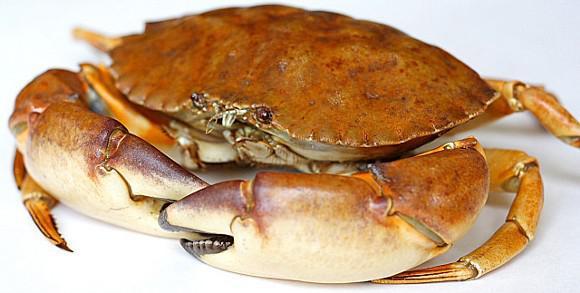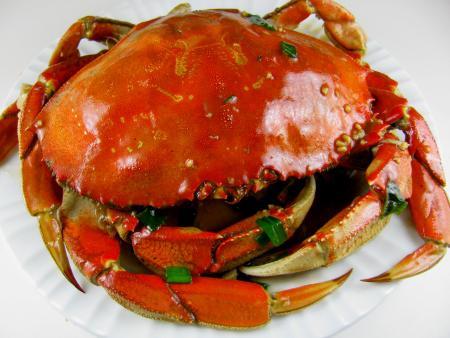The first image is the image on the left, the second image is the image on the right. For the images shown, is this caption "There is only one crab in at least one of the images." true? Answer yes or no. Yes. The first image is the image on the left, the second image is the image on the right. Assess this claim about the two images: "All images include at least one forward-facing reddish-orange crab with its shell intact.". Correct or not? Answer yes or no. Yes. 